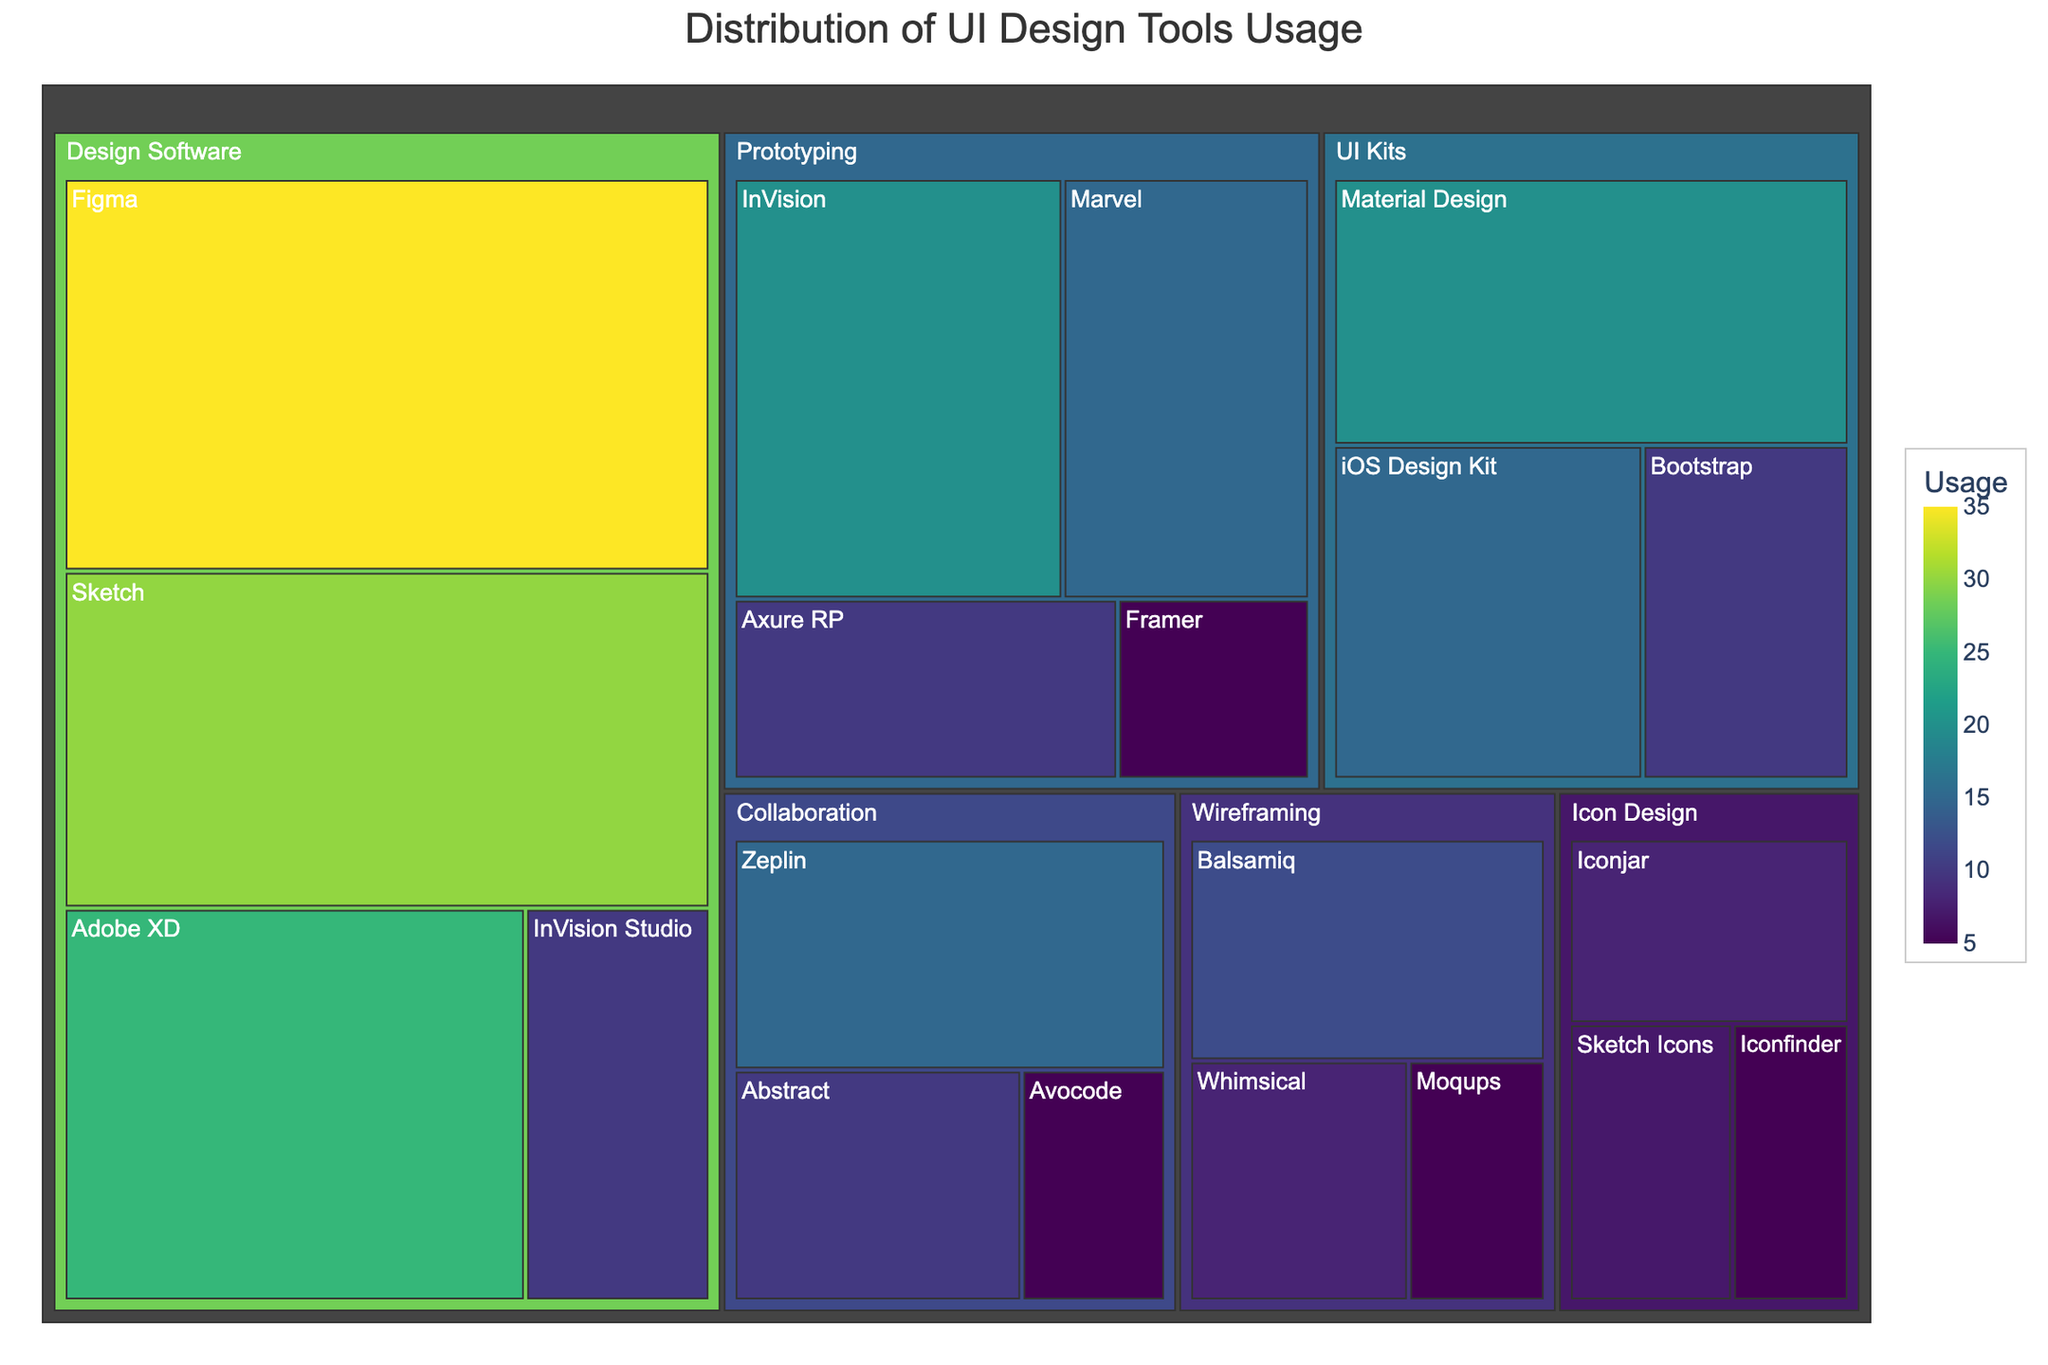What is the title of the treemap? The title is usually displayed prominently at the top of the treemap figure. By checking the figure, we see the title provided.
Answer: Distribution of UI Design Tools Usage Which category contains the tool with the highest usage? By examining the size of the blocks associated with each tool in different categories, we identify the tool with the highest usage and its category.
Answer: Design Software Which tool in the Icon Design category has the lowest usage? Look at the Icon Design category's section in the treemap, then identify the smallest block, which represents the lowest usage.
Answer: Iconfinder What is the combined usage of Balsamiq and Moqups? Locate the blocks for Balsamiq and Moqups in the Wireframing category. Add their respective usage values: 12 (Balsamiq) + 5 (Moqups).
Answer: 17 Compare the usage of Sketch and Adobe XD. Which one is more popular and by how much? Find the blocks for Sketch and Adobe XD in the treemap and note their usage values. Subtract the smaller usage value from the larger one: 30 (Sketch) - 25 (Adobe XD).
Answer: Sketch by 5 How many categories are represented in the treemap? Each top-level block in the treemap represents a distinct category. Count these blocks.
Answer: 5 What is the total usage of tools in the Collaboration category? Sum the usage of all tools in the Collaboration category: 15 (Zeplin) + 10 (Abstract) + 5 (Avocode).
Answer: 30 Which prototyping tool has the highest usage, and what is its value? Look at the Prototyping category in the treemap, identify the largest block, and read its usage value.
Answer: InVision with 20 Is there any tool in the Wireframing category that has a usage higher than 10? Examine the Wireframing blocks and find if any have values greater than 10. Only Balsamiq has a value of 12, which is higher than 10.
Answer: Yes, Balsamiq What is the average usage of the tools in the UI Kits category? Sum the usage values of all tools in the UI Kits category and divide by the number of tools: (20 + 15 + 10) / 3 = 45 / 3.
Answer: 15 